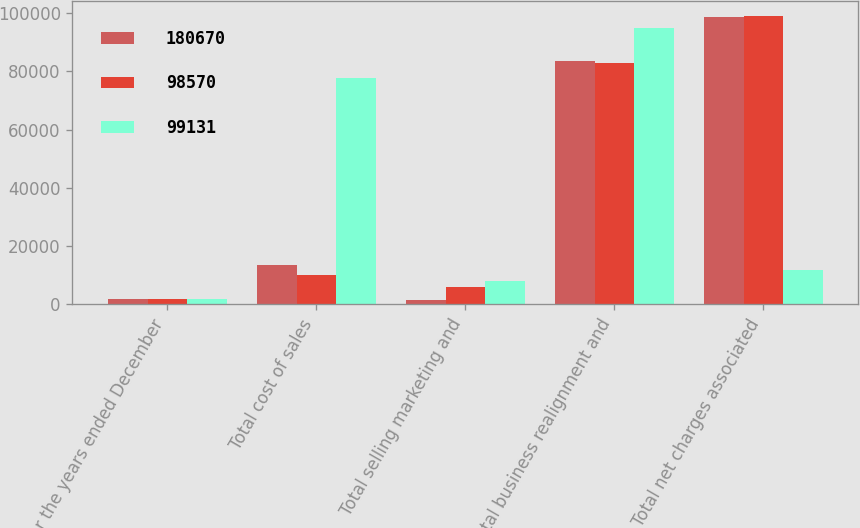Convert chart. <chart><loc_0><loc_0><loc_500><loc_500><stacked_bar_chart><ecel><fcel>For the years ended December<fcel>Total cost of sales<fcel>Total selling marketing and<fcel>Total business realignment and<fcel>Total net charges associated<nl><fcel>180670<fcel>2010<fcel>13644<fcel>1493<fcel>83433<fcel>98570<nl><fcel>98570<fcel>2009<fcel>10136<fcel>6120<fcel>82875<fcel>99131<nl><fcel>99131<fcel>2008<fcel>77767<fcel>8102<fcel>94801<fcel>11890<nl></chart> 